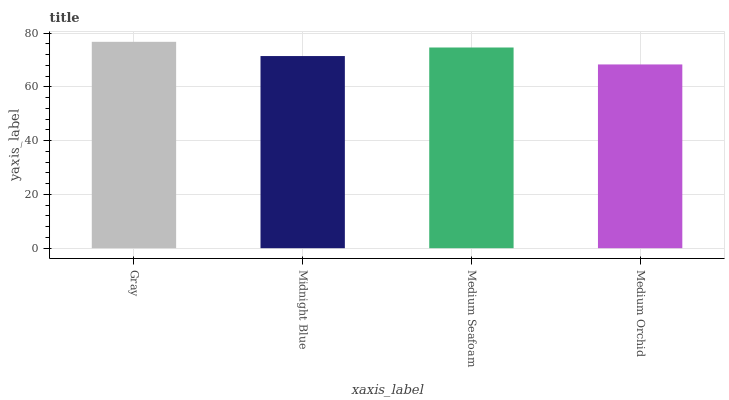Is Medium Orchid the minimum?
Answer yes or no. Yes. Is Gray the maximum?
Answer yes or no. Yes. Is Midnight Blue the minimum?
Answer yes or no. No. Is Midnight Blue the maximum?
Answer yes or no. No. Is Gray greater than Midnight Blue?
Answer yes or no. Yes. Is Midnight Blue less than Gray?
Answer yes or no. Yes. Is Midnight Blue greater than Gray?
Answer yes or no. No. Is Gray less than Midnight Blue?
Answer yes or no. No. Is Medium Seafoam the high median?
Answer yes or no. Yes. Is Midnight Blue the low median?
Answer yes or no. Yes. Is Medium Orchid the high median?
Answer yes or no. No. Is Medium Seafoam the low median?
Answer yes or no. No. 